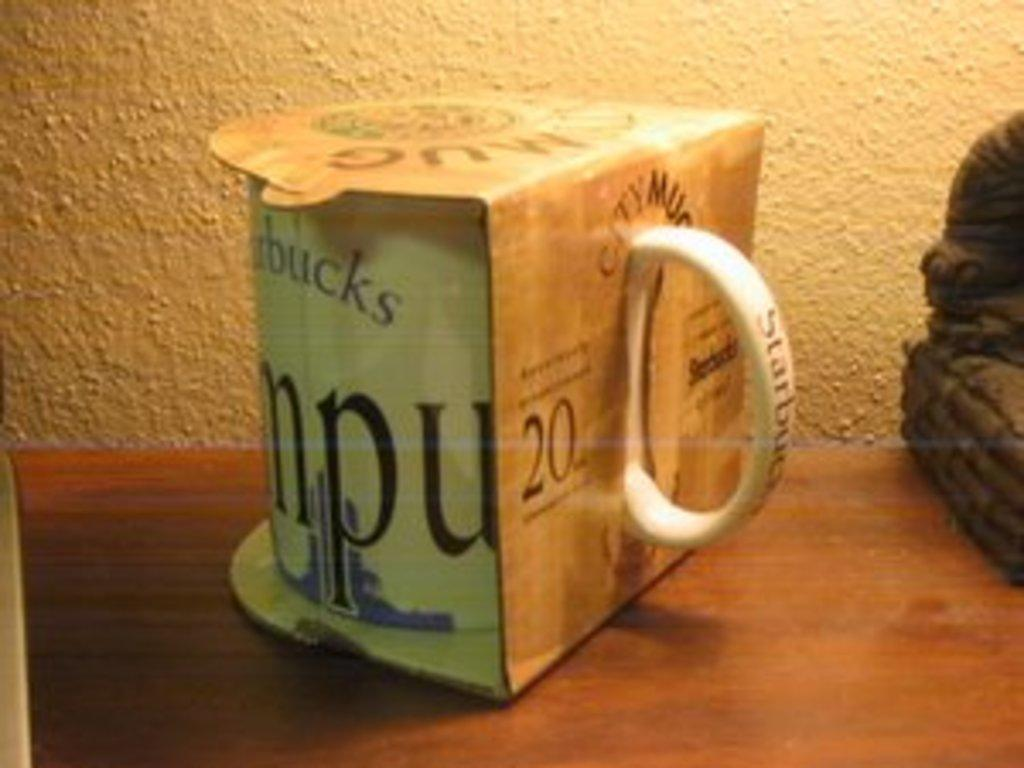Provide a one-sentence caption for the provided image. White Starbucks cup still inside it's cover and unopened. 